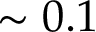Convert formula to latex. <formula><loc_0><loc_0><loc_500><loc_500>\sim 0 . 1</formula> 